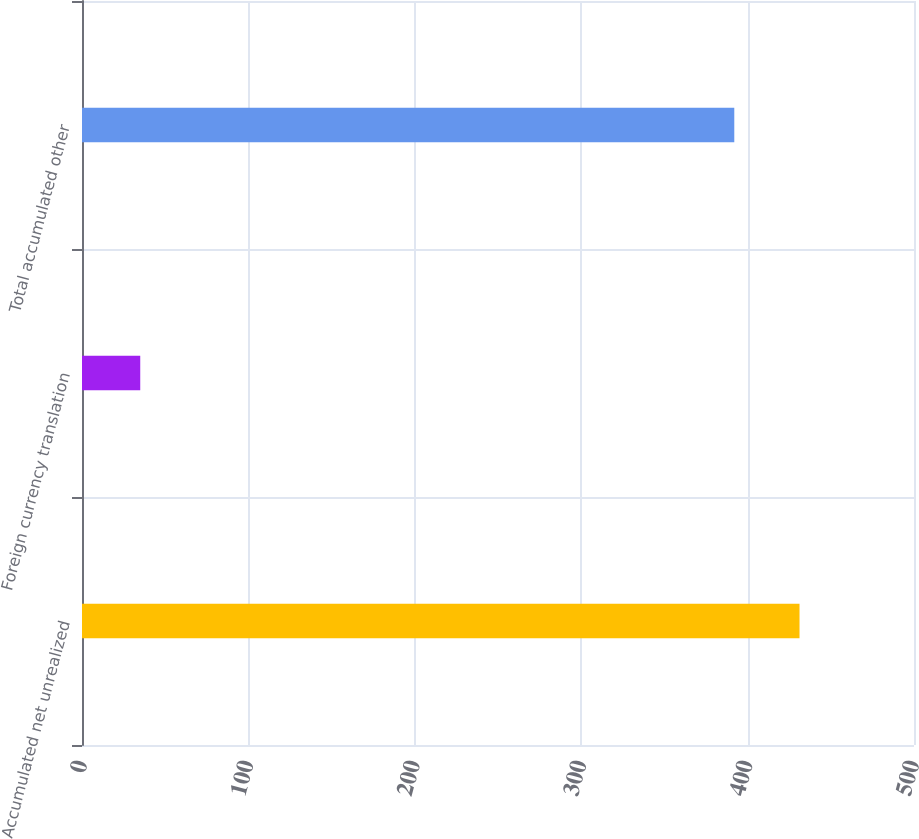Convert chart to OTSL. <chart><loc_0><loc_0><loc_500><loc_500><bar_chart><fcel>Accumulated net unrealized<fcel>Foreign currency translation<fcel>Total accumulated other<nl><fcel>431.2<fcel>35<fcel>392<nl></chart> 